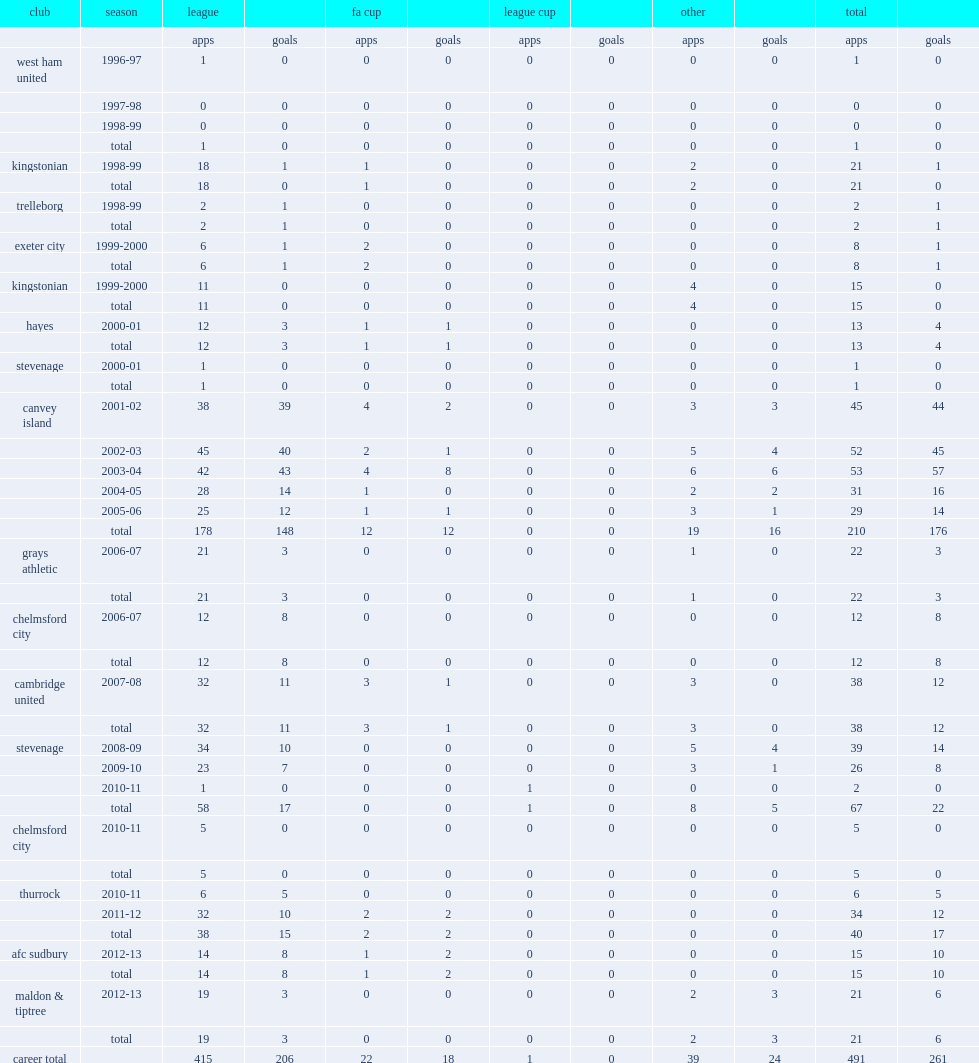How many goals did boylan score for canvey island in his five-year tenure? 176.0. Parse the full table. {'header': ['club', 'season', 'league', '', 'fa cup', '', 'league cup', '', 'other', '', 'total', ''], 'rows': [['', '', 'apps', 'goals', 'apps', 'goals', 'apps', 'goals', 'apps', 'goals', 'apps', 'goals'], ['west ham united', '1996-97', '1', '0', '0', '0', '0', '0', '0', '0', '1', '0'], ['', '1997-98', '0', '0', '0', '0', '0', '0', '0', '0', '0', '0'], ['', '1998-99', '0', '0', '0', '0', '0', '0', '0', '0', '0', '0'], ['', 'total', '1', '0', '0', '0', '0', '0', '0', '0', '1', '0'], ['kingstonian', '1998-99', '18', '1', '1', '0', '0', '0', '2', '0', '21', '1'], ['', 'total', '18', '0', '1', '0', '0', '0', '2', '0', '21', '0'], ['trelleborg', '1998-99', '2', '1', '0', '0', '0', '0', '0', '0', '2', '1'], ['', 'total', '2', '1', '0', '0', '0', '0', '0', '0', '2', '1'], ['exeter city', '1999-2000', '6', '1', '2', '0', '0', '0', '0', '0', '8', '1'], ['', 'total', '6', '1', '2', '0', '0', '0', '0', '0', '8', '1'], ['kingstonian', '1999-2000', '11', '0', '0', '0', '0', '0', '4', '0', '15', '0'], ['', 'total', '11', '0', '0', '0', '0', '0', '4', '0', '15', '0'], ['hayes', '2000-01', '12', '3', '1', '1', '0', '0', '0', '0', '13', '4'], ['', 'total', '12', '3', '1', '1', '0', '0', '0', '0', '13', '4'], ['stevenage', '2000-01', '1', '0', '0', '0', '0', '0', '0', '0', '1', '0'], ['', 'total', '1', '0', '0', '0', '0', '0', '0', '0', '1', '0'], ['canvey island', '2001-02', '38', '39', '4', '2', '0', '0', '3', '3', '45', '44'], ['', '2002-03', '45', '40', '2', '1', '0', '0', '5', '4', '52', '45'], ['', '2003-04', '42', '43', '4', '8', '0', '0', '6', '6', '53', '57'], ['', '2004-05', '28', '14', '1', '0', '0', '0', '2', '2', '31', '16'], ['', '2005-06', '25', '12', '1', '1', '0', '0', '3', '1', '29', '14'], ['', 'total', '178', '148', '12', '12', '0', '0', '19', '16', '210', '176'], ['grays athletic', '2006-07', '21', '3', '0', '0', '0', '0', '1', '0', '22', '3'], ['', 'total', '21', '3', '0', '0', '0', '0', '1', '0', '22', '3'], ['chelmsford city', '2006-07', '12', '8', '0', '0', '0', '0', '0', '0', '12', '8'], ['', 'total', '12', '8', '0', '0', '0', '0', '0', '0', '12', '8'], ['cambridge united', '2007-08', '32', '11', '3', '1', '0', '0', '3', '0', '38', '12'], ['', 'total', '32', '11', '3', '1', '0', '0', '3', '0', '38', '12'], ['stevenage', '2008-09', '34', '10', '0', '0', '0', '0', '5', '4', '39', '14'], ['', '2009-10', '23', '7', '0', '0', '0', '0', '3', '1', '26', '8'], ['', '2010-11', '1', '0', '0', '0', '1', '0', '0', '0', '2', '0'], ['', 'total', '58', '17', '0', '0', '1', '0', '8', '5', '67', '22'], ['chelmsford city', '2010-11', '5', '0', '0', '0', '0', '0', '0', '0', '5', '0'], ['', 'total', '5', '0', '0', '0', '0', '0', '0', '0', '5', '0'], ['thurrock', '2010-11', '6', '5', '0', '0', '0', '0', '0', '0', '6', '5'], ['', '2011-12', '32', '10', '2', '2', '0', '0', '0', '0', '34', '12'], ['', 'total', '38', '15', '2', '2', '0', '0', '0', '0', '40', '17'], ['afc sudbury', '2012-13', '14', '8', '1', '2', '0', '0', '0', '0', '15', '10'], ['', 'total', '14', '8', '1', '2', '0', '0', '0', '0', '15', '10'], ['maldon & tiptree', '2012-13', '19', '3', '0', '0', '0', '0', '2', '3', '21', '6'], ['', 'total', '19', '3', '0', '0', '0', '0', '2', '3', '21', '6'], ['career total', '', '415', '206', '22', '18', '1', '0', '39', '24', '491', '261']]} 